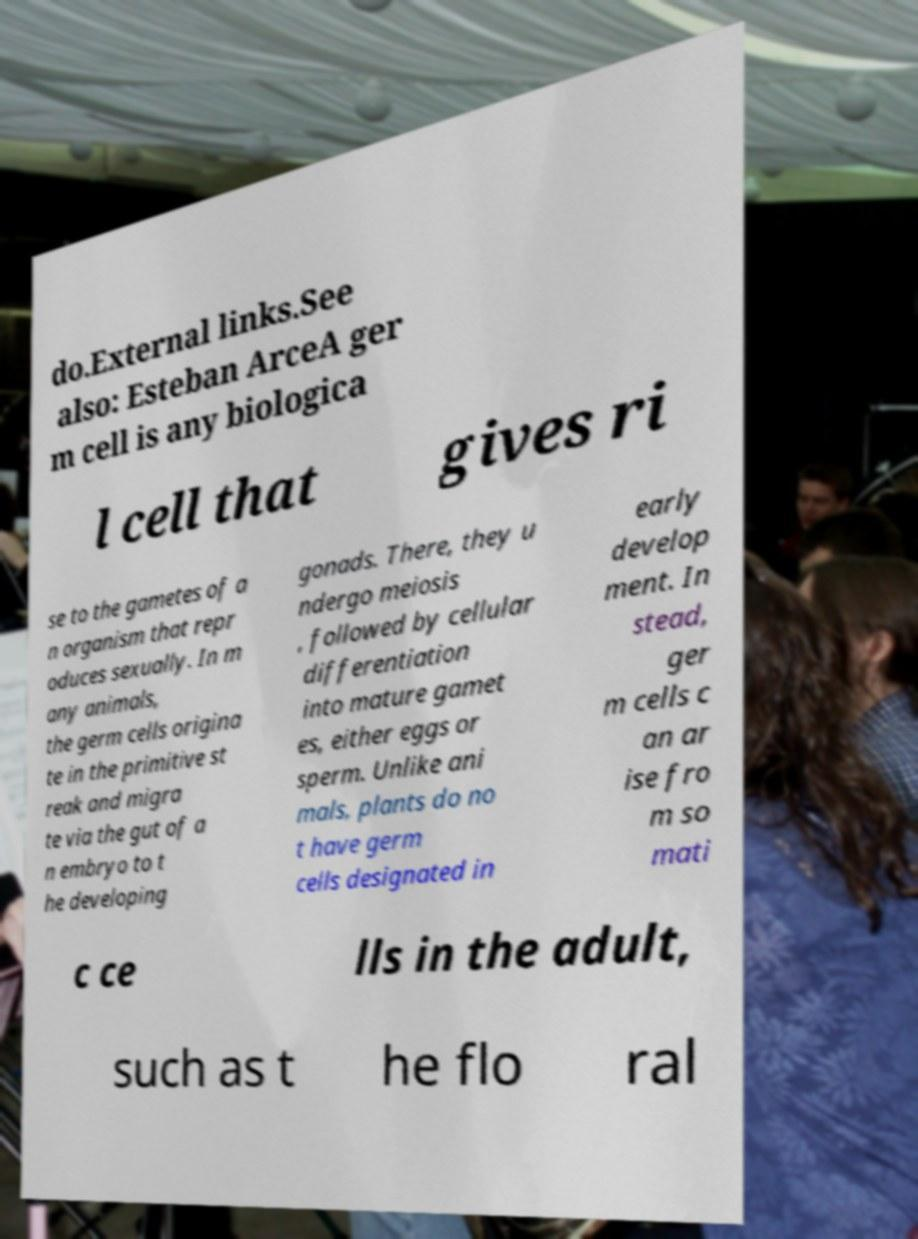For documentation purposes, I need the text within this image transcribed. Could you provide that? do.External links.See also: Esteban ArceA ger m cell is any biologica l cell that gives ri se to the gametes of a n organism that repr oduces sexually. In m any animals, the germ cells origina te in the primitive st reak and migra te via the gut of a n embryo to t he developing gonads. There, they u ndergo meiosis , followed by cellular differentiation into mature gamet es, either eggs or sperm. Unlike ani mals, plants do no t have germ cells designated in early develop ment. In stead, ger m cells c an ar ise fro m so mati c ce lls in the adult, such as t he flo ral 